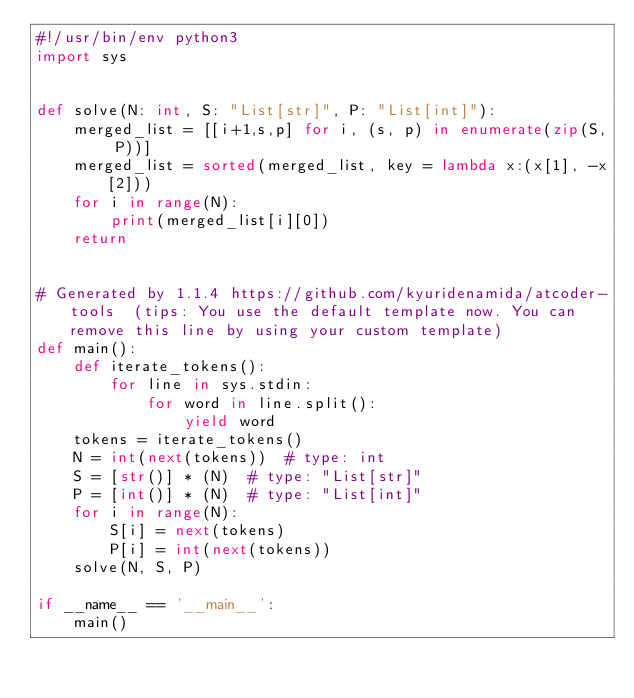<code> <loc_0><loc_0><loc_500><loc_500><_Python_>#!/usr/bin/env python3
import sys


def solve(N: int, S: "List[str]", P: "List[int]"):
    merged_list = [[i+1,s,p] for i, (s, p) in enumerate(zip(S, P))]
    merged_list = sorted(merged_list, key = lambda x:(x[1], -x[2]))
    for i in range(N):
        print(merged_list[i][0])
    return


# Generated by 1.1.4 https://github.com/kyuridenamida/atcoder-tools  (tips: You use the default template now. You can remove this line by using your custom template)
def main():
    def iterate_tokens():
        for line in sys.stdin:
            for word in line.split():
                yield word
    tokens = iterate_tokens()
    N = int(next(tokens))  # type: int
    S = [str()] * (N)  # type: "List[str]" 
    P = [int()] * (N)  # type: "List[int]" 
    for i in range(N):
        S[i] = next(tokens)
        P[i] = int(next(tokens))
    solve(N, S, P)

if __name__ == '__main__':
    main()
</code> 